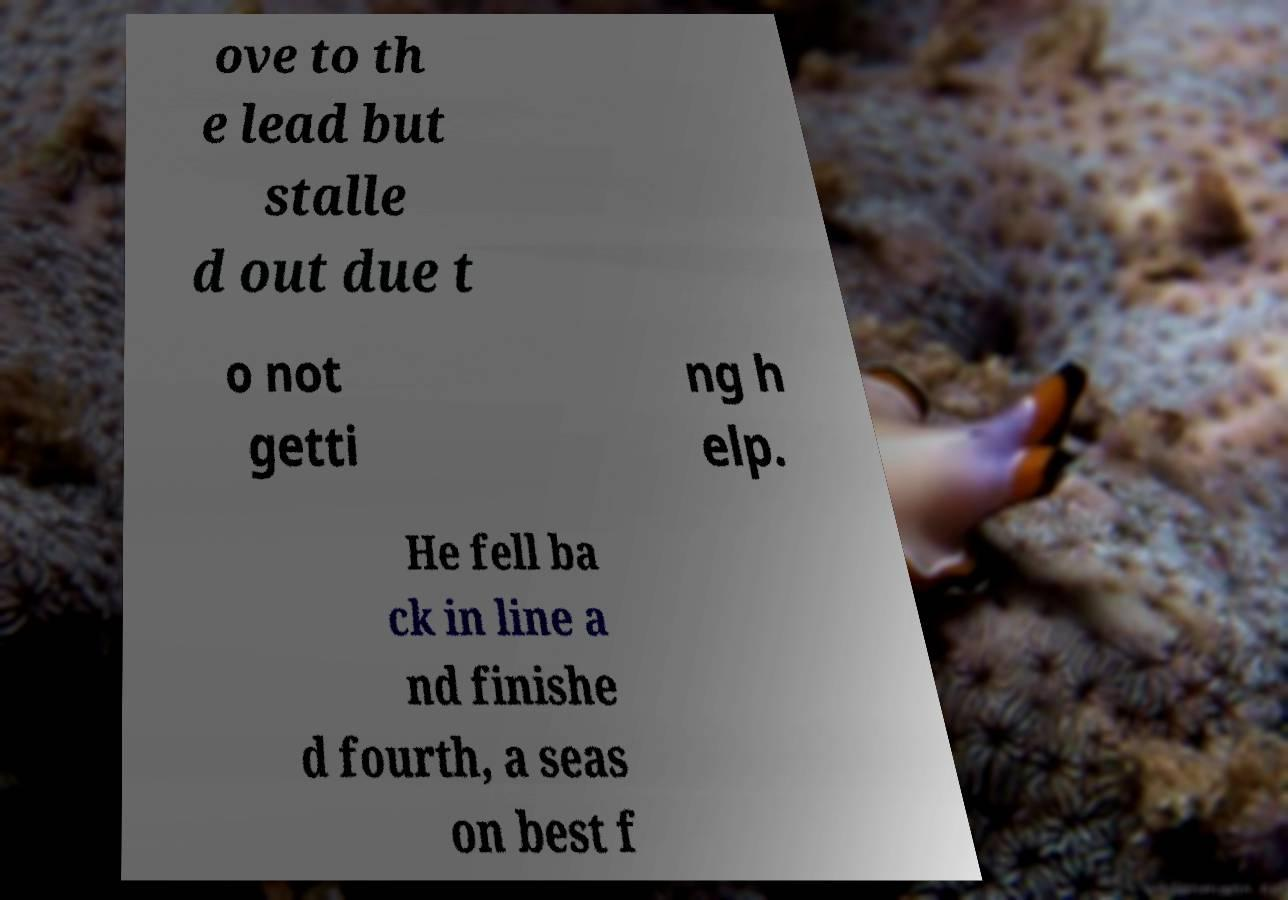Could you assist in decoding the text presented in this image and type it out clearly? ove to th e lead but stalle d out due t o not getti ng h elp. He fell ba ck in line a nd finishe d fourth, a seas on best f 